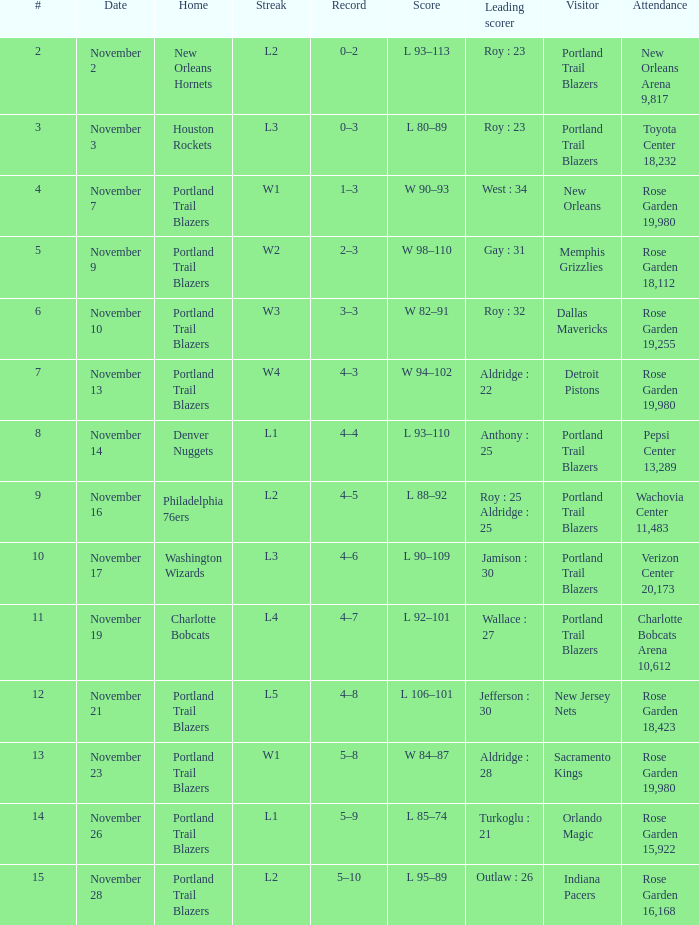What is the total number of date where visitor is new jersey nets 1.0. 